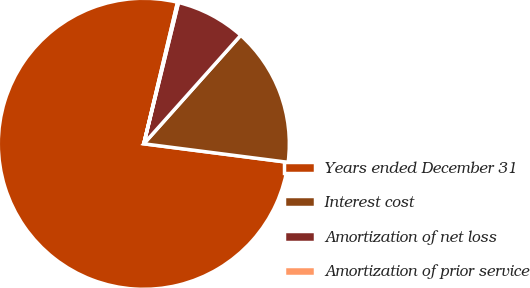Convert chart to OTSL. <chart><loc_0><loc_0><loc_500><loc_500><pie_chart><fcel>Years ended December 31<fcel>Interest cost<fcel>Amortization of net loss<fcel>Amortization of prior service<nl><fcel>76.68%<fcel>15.43%<fcel>7.77%<fcel>0.11%<nl></chart> 